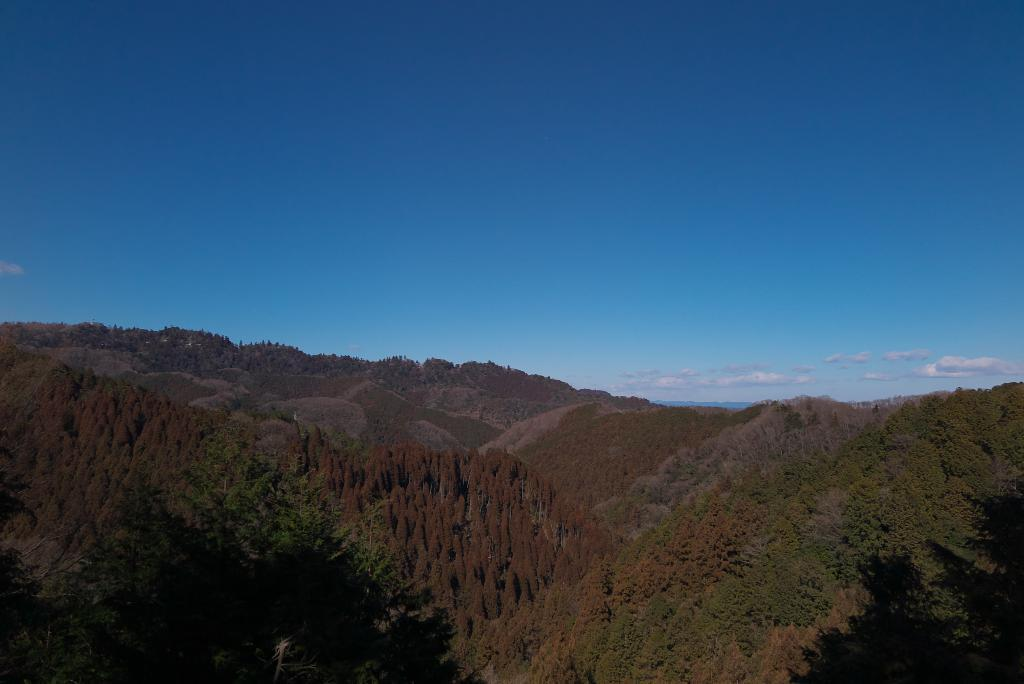What type of natural features can be seen in the image? There are trees and mountains in the image. What is visible in the sky in the image? Clouds are visible in the sky in the image. What type of pancake is being bitten by the rod in the image? There is no pancake or rod present in the image. 